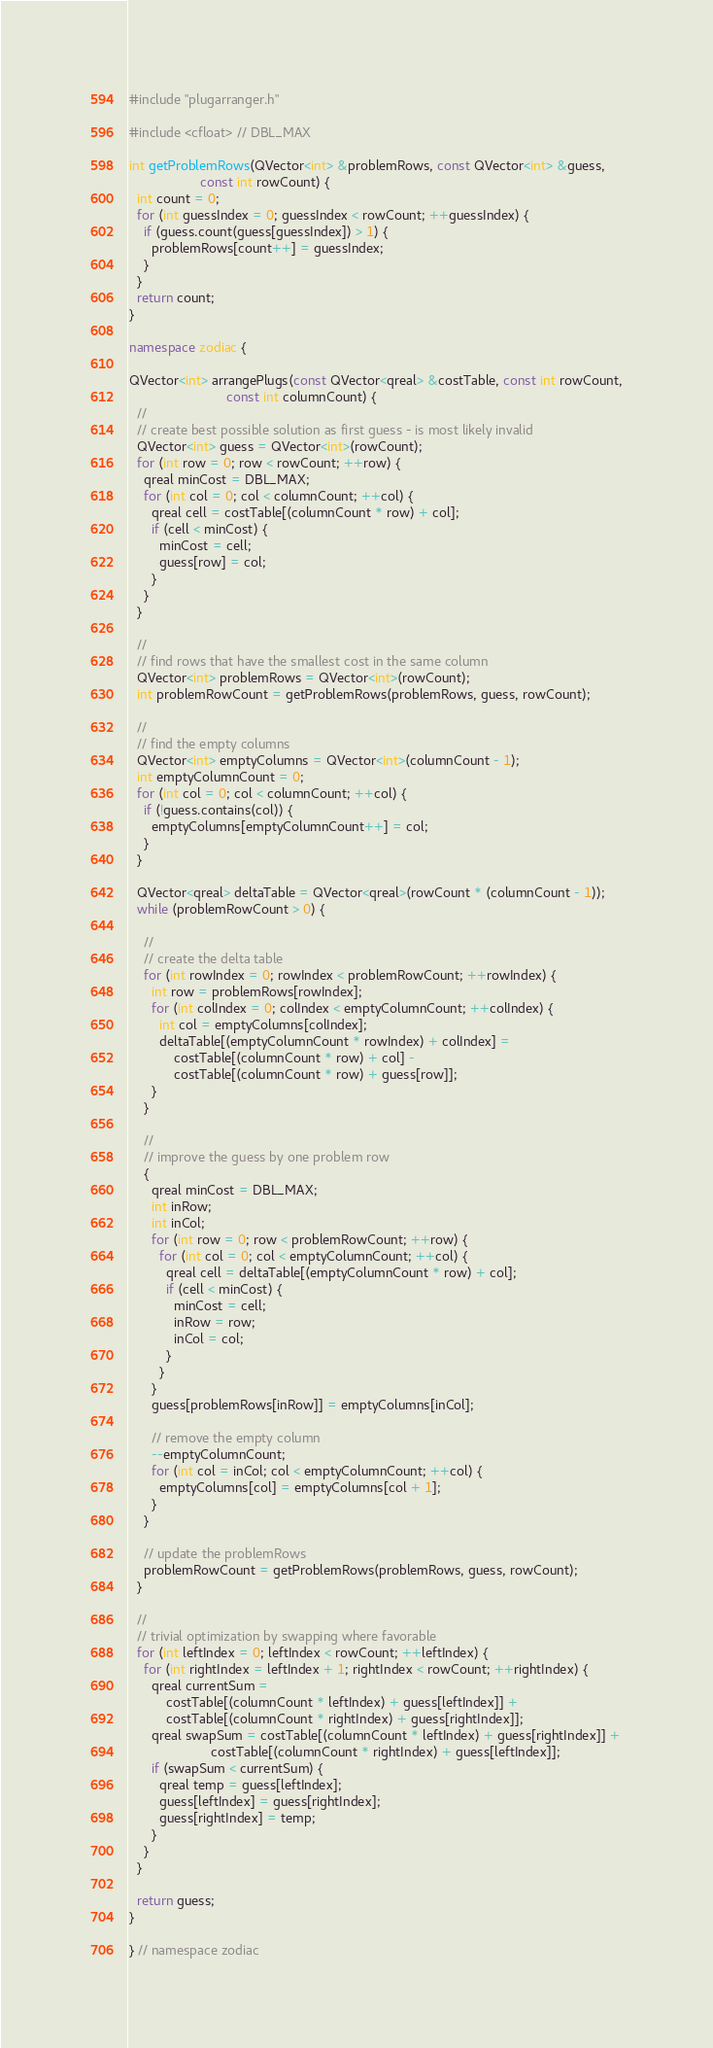<code> <loc_0><loc_0><loc_500><loc_500><_C++_>#include "plugarranger.h"

#include <cfloat> // DBL_MAX

int getProblemRows(QVector<int> &problemRows, const QVector<int> &guess,
                   const int rowCount) {
  int count = 0;
  for (int guessIndex = 0; guessIndex < rowCount; ++guessIndex) {
    if (guess.count(guess[guessIndex]) > 1) {
      problemRows[count++] = guessIndex;
    }
  }
  return count;
}

namespace zodiac {

QVector<int> arrangePlugs(const QVector<qreal> &costTable, const int rowCount,
                          const int columnCount) {
  //
  // create best possible solution as first guess - is most likely invalid
  QVector<int> guess = QVector<int>(rowCount);
  for (int row = 0; row < rowCount; ++row) {
    qreal minCost = DBL_MAX;
    for (int col = 0; col < columnCount; ++col) {
      qreal cell = costTable[(columnCount * row) + col];
      if (cell < minCost) {
        minCost = cell;
        guess[row] = col;
      }
    }
  }

  //
  // find rows that have the smallest cost in the same column
  QVector<int> problemRows = QVector<int>(rowCount);
  int problemRowCount = getProblemRows(problemRows, guess, rowCount);

  //
  // find the empty columns
  QVector<int> emptyColumns = QVector<int>(columnCount - 1);
  int emptyColumnCount = 0;
  for (int col = 0; col < columnCount; ++col) {
    if (!guess.contains(col)) {
      emptyColumns[emptyColumnCount++] = col;
    }
  }

  QVector<qreal> deltaTable = QVector<qreal>(rowCount * (columnCount - 1));
  while (problemRowCount > 0) {

    //
    // create the delta table
    for (int rowIndex = 0; rowIndex < problemRowCount; ++rowIndex) {
      int row = problemRows[rowIndex];
      for (int colIndex = 0; colIndex < emptyColumnCount; ++colIndex) {
        int col = emptyColumns[colIndex];
        deltaTable[(emptyColumnCount * rowIndex) + colIndex] =
            costTable[(columnCount * row) + col] -
            costTable[(columnCount * row) + guess[row]];
      }
    }

    //
    // improve the guess by one problem row
    {
      qreal minCost = DBL_MAX;
      int inRow;
      int inCol;
      for (int row = 0; row < problemRowCount; ++row) {
        for (int col = 0; col < emptyColumnCount; ++col) {
          qreal cell = deltaTable[(emptyColumnCount * row) + col];
          if (cell < minCost) {
            minCost = cell;
            inRow = row;
            inCol = col;
          }
        }
      }
      guess[problemRows[inRow]] = emptyColumns[inCol];

      // remove the empty column
      --emptyColumnCount;
      for (int col = inCol; col < emptyColumnCount; ++col) {
        emptyColumns[col] = emptyColumns[col + 1];
      }
    }

    // update the problemRows
    problemRowCount = getProblemRows(problemRows, guess, rowCount);
  }

  //
  // trivial optimization by swapping where favorable
  for (int leftIndex = 0; leftIndex < rowCount; ++leftIndex) {
    for (int rightIndex = leftIndex + 1; rightIndex < rowCount; ++rightIndex) {
      qreal currentSum =
          costTable[(columnCount * leftIndex) + guess[leftIndex]] +
          costTable[(columnCount * rightIndex) + guess[rightIndex]];
      qreal swapSum = costTable[(columnCount * leftIndex) + guess[rightIndex]] +
                      costTable[(columnCount * rightIndex) + guess[leftIndex]];
      if (swapSum < currentSum) {
        qreal temp = guess[leftIndex];
        guess[leftIndex] = guess[rightIndex];
        guess[rightIndex] = temp;
      }
    }
  }

  return guess;
}

} // namespace zodiac
</code> 